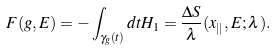Convert formula to latex. <formula><loc_0><loc_0><loc_500><loc_500>F ( g , E ) = - \int _ { \gamma _ { g } ( t ) } d t H _ { 1 } = \frac { \Delta S } { \lambda } ( { x } _ { | | } , E ; \lambda ) .</formula> 